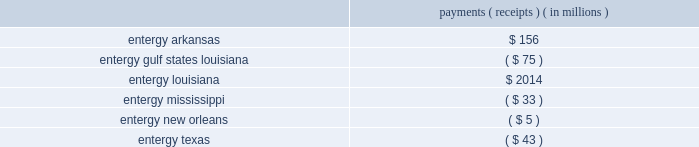Entergy corporation and subsidiaries notes to financial statements equitable discretion and not require refunds for the 20-month period from september 13 , 2001 - may 2 , 2003 .
Because the ruling on refunds relied on findings in the interruptible load proceeding , which is discussed in a separate section below , the ferc concluded that the refund ruling will be held in abeyance pending the outcome of the rehearing requests in that proceeding .
On the second issue , the ferc reversed its prior decision and ordered that the prospective bandwidth remedy begin on june 1 , 2005 ( the date of its initial order in the proceeding ) rather than january 1 , 2006 , as it had previously ordered .
Pursuant to the october 2011 order , entergy was required to calculate the additional bandwidth payments for the period june - december 2005 utilizing the bandwidth formula tariff prescribed by the ferc that was filed in a december 2006 compliance filing and accepted by the ferc in an april 2007 order .
As is the case with bandwidth remedy payments , these payments and receipts will ultimately be paid by utility operating company customers to other utility operating company customers .
In december 2011 , entergy filed with the ferc its compliance filing that provides the payments and receipts among the utility operating companies pursuant to the ferc 2019s october 2011 order .
The filing shows the following payments/receipts among the utility operating companies : payments ( receipts ) ( in millions ) .
Entergy arkansas made its payment in january 2012 .
In february 2012 , entergy arkansas filed for an interim adjustment to its production cost allocation rider requesting that the $ 156 million payment be collected from customers over the 22-month period from march 2012 through december 2013 .
In march 2012 the apsc issued an order stating that the payment can be recovered from retail customers through the production cost allocation rider , subject to refund .
The lpsc and the apsc have requested rehearing of the ferc 2019s october 2011 order .
In december 2013 the lpsc filed a petition for a writ of mandamus at the united states court of appeals for the d.c .
Circuit .
In its petition , the lpsc requested that the d.c .
Circuit issue an order compelling the ferc to issue a final order on pending rehearing requests .
In its response to the lpsc petition , the ferc committed to rule on the pending rehearing request before the end of february .
In january 2014 the d.c .
Circuit denied the lpsc's petition .
The apsc , the lpsc , the puct , and other parties intervened in the december 2011 compliance filing proceeding , and the apsc and the lpsc also filed protests .
Calendar year 2013 production costs the liabilities and assets for the preliminary estimate of the payments and receipts required to implement the ferc 2019s remedy based on calendar year 2013 production costs were recorded in december 2013 , based on certain year-to-date information .
The preliminary estimate was recorded based on the following estimate of the payments/receipts among the utility operating companies for 2014. .
What portion of the entergy arkansas payment goes to entergy mississippi? 
Computations: (33 / 156)
Answer: 0.21154. 